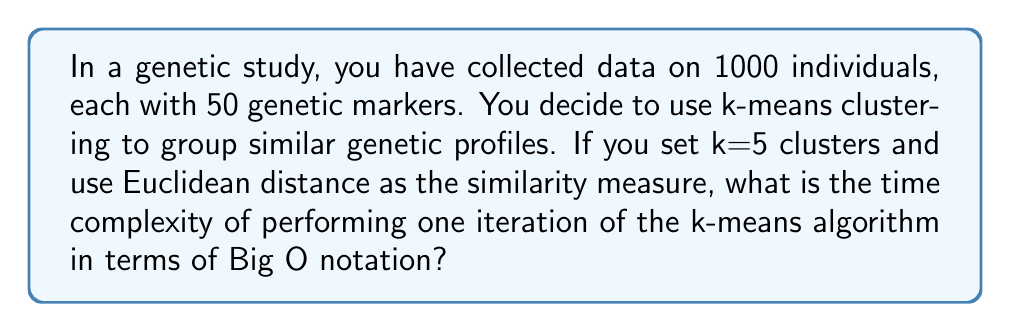What is the answer to this math problem? To determine the time complexity of one iteration of the k-means algorithm, let's break down the steps:

1. We have:
   - n = 1000 (number of individuals)
   - d = 50 (number of genetic markers, i.e., dimensions)
   - k = 5 (number of clusters)

2. One iteration of k-means consists of two main steps:
   a) Assigning each point to the nearest centroid
   b) Recalculating the centroids

3. For step a:
   - We need to calculate the distance between each point and each centroid
   - For each point (n times):
     - We calculate the distance to each centroid (k times)
     - Each distance calculation involves d dimensions
   - Time complexity for this step: $O(n * k * d)$

4. For step b:
   - We need to recalculate the mean for each cluster
   - For each cluster (k times):
     - We sum up all points in the cluster (worst case: n points)
     - Each point has d dimensions
   - Time complexity for this step: $O(k * n * d)$

5. Combining both steps:
   $O(n * k * d) + O(k * n * d) = O(n * k * d)$

Therefore, the time complexity of one iteration of the k-means algorithm in this case is $O(n * k * d)$.
Answer: $O(n * k * d)$ 